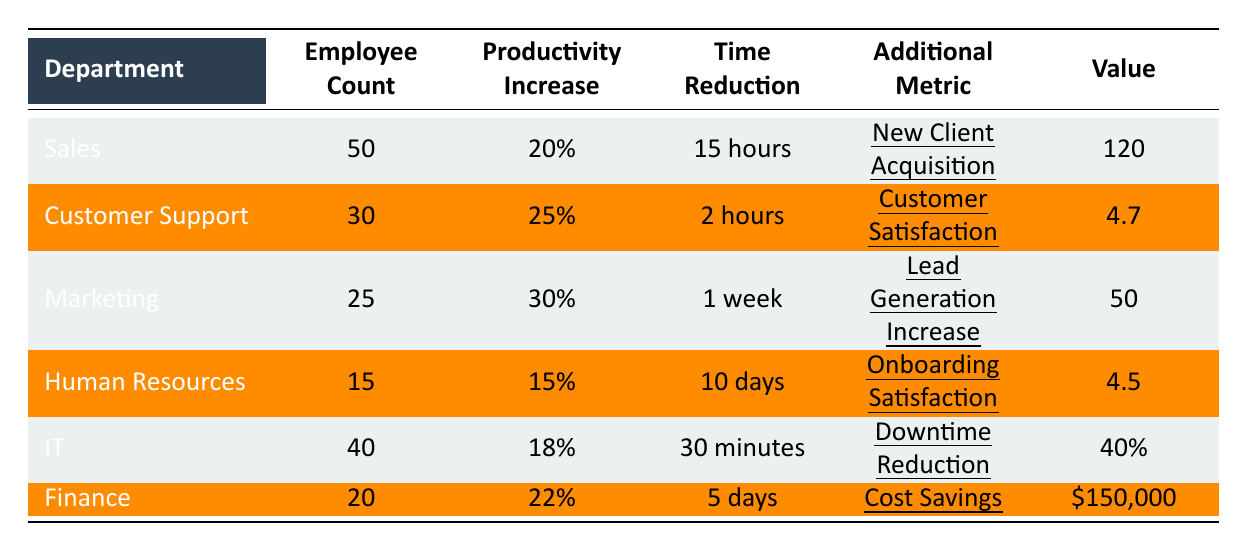What's the productivity increase percentage for the Marketing department? The table shows that the Marketing department has a Productivity Increase Percentage of 30%.
Answer: 30% How many employees are in the Customer Support department? The table indicates that the Customer Support department has a total of 30 employees.
Answer: 30 What is the average time reduction across all departments listed? The time reductions are: 15 hours (Sales), 2 hours (Customer Support), 1 week (7 days for Marketing), 10 days (HR), 30 minutes (IT), and 5 days (Finance). To get the average, we convert everything to hours: 15, 2, 168 (1 week), 240 (10 days), 0.5 (30 minutes), and 120 (5 days). Summing these gives 545 hours, and dividing by 6 (number of departments) gives approximately 90.83 hours.
Answer: 90.83 hours Is the Customer Satisfaction Score greater than 4.5 in any department? Yes, the Customer Support department has a Customer Satisfaction Score of 4.7, which is indeed greater than 4.5.
Answer: Yes Which department had the lowest productivity increase percentage? The table indicates that the Human Resources department had the lowest productivity increase percentage at 15%.
Answer: 15% How much cost savings did the Finance department achieve compared to the productivity increase percentage of the IT department? The Finance department achieved cost savings of $150,000 and has a productivity increase of 22%. The IT department has a productivity increase of 18%. While the specific relationship is not calculable as they are different metrics, it can be summarized that the Finance department has a significant cost savings despite a slightly higher productivity increase percentage compared to IT.
Answer: $150,000 vs. 22% vs. 18% What is the ratio of the Employee Count between the Sales and Human Resources departments? The Sales department has 50 employees, while Human Resources has 15 employees. The ratio is 50:15, which simplifies to 10:3.
Answer: 10:3 Which department had the highest lead generation increase? The table shows that the Marketing department had the highest lead generation increase at 50.
Answer: 50 Calculate the difference in New Client Acquisition and Employee Count between Sales and Finance. Sales has 120 New Client Acquisitions and 50 employees. Finance has no New Client Acquisition metric but has 20 employees. Since Finance has no comparable metric, we will just consider the Employee Count: Sales has 50 employees and Finance has 20 employees, which is a difference of 30. For New Client Acquisition, it remains solitary as Finance does not account for it.
Answer: New Client Acquisition: 120, Employee Count difference: 30 Which department has the fastest average resolution time reduction? The table indicates that the Customer Support department has the fastest average resolution time reduction of 2 hours, making it the quickest.
Answer: 2 hours 